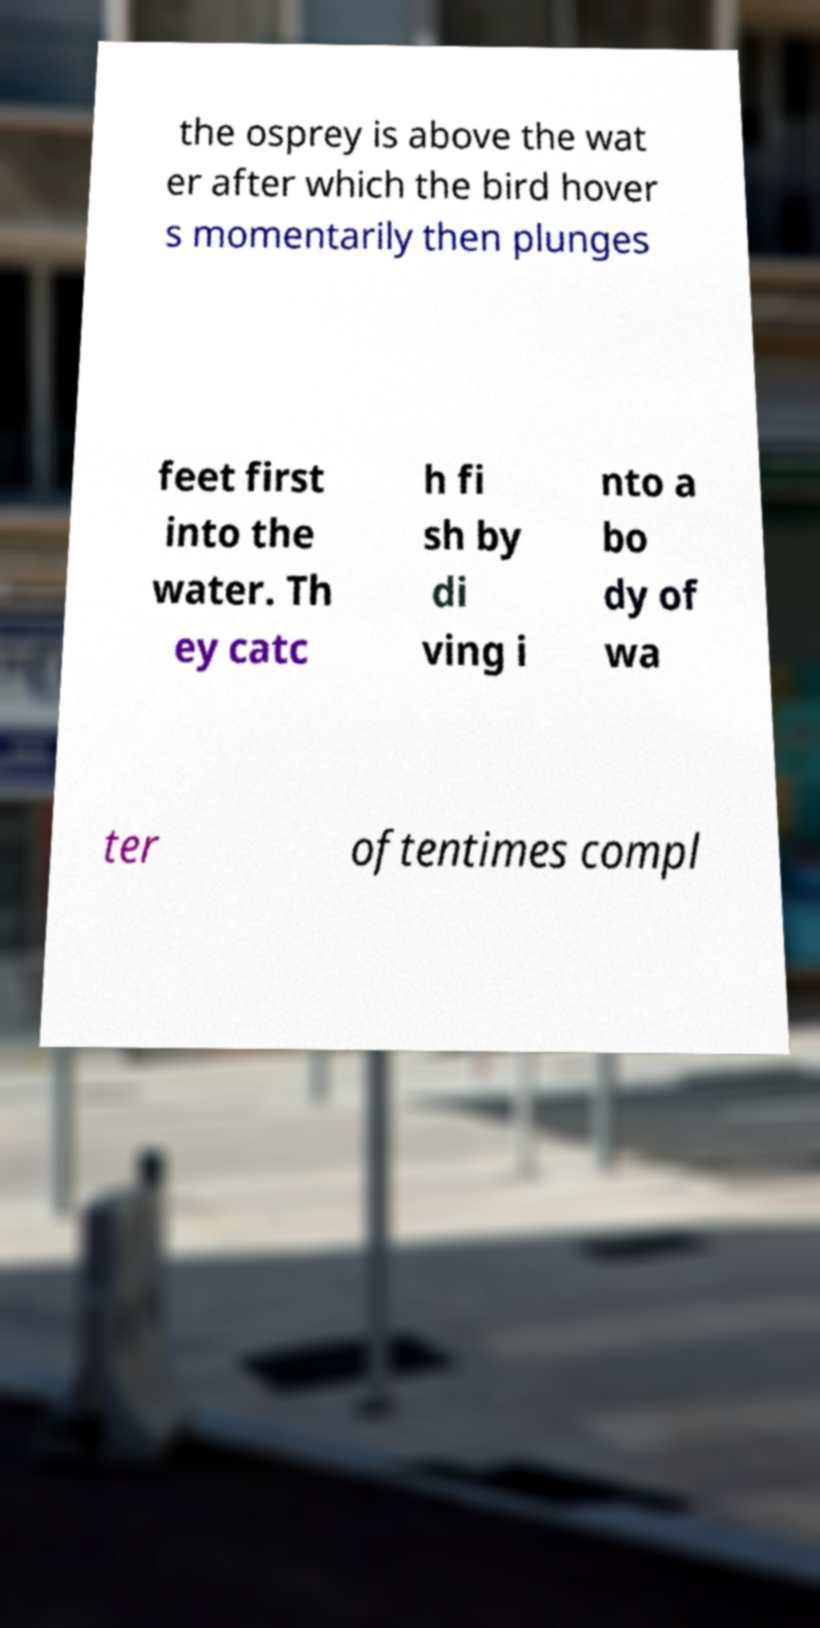For documentation purposes, I need the text within this image transcribed. Could you provide that? the osprey is above the wat er after which the bird hover s momentarily then plunges feet first into the water. Th ey catc h fi sh by di ving i nto a bo dy of wa ter oftentimes compl 